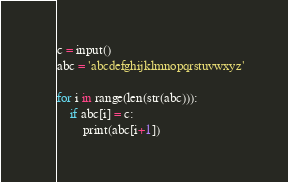Convert code to text. <code><loc_0><loc_0><loc_500><loc_500><_Python_>c = input()
abc = 'abcdefghijklmnopqrstuvwxyz'

for i in range(len(str(abc))):
    if abc[i] = c:
        print(abc[i+1])</code> 